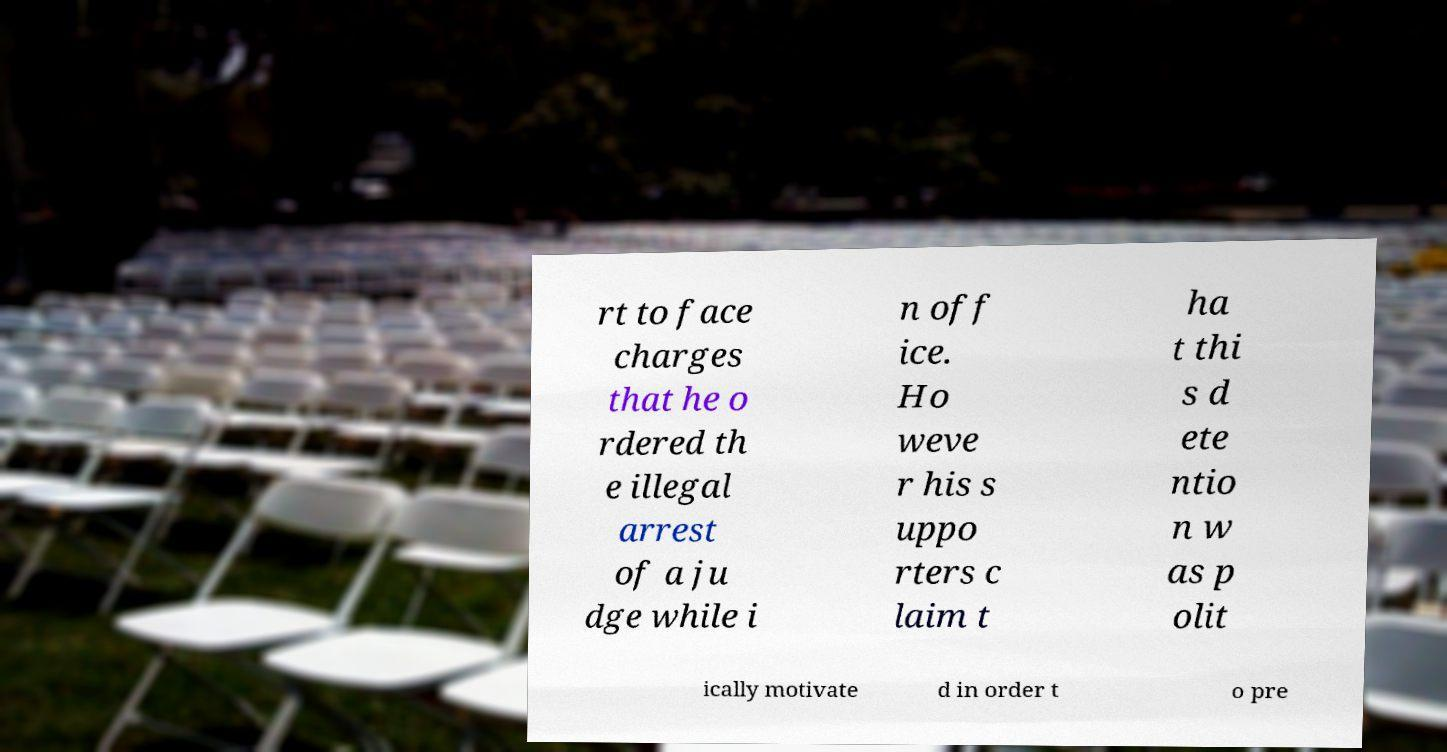Please identify and transcribe the text found in this image. rt to face charges that he o rdered th e illegal arrest of a ju dge while i n off ice. Ho weve r his s uppo rters c laim t ha t thi s d ete ntio n w as p olit ically motivate d in order t o pre 